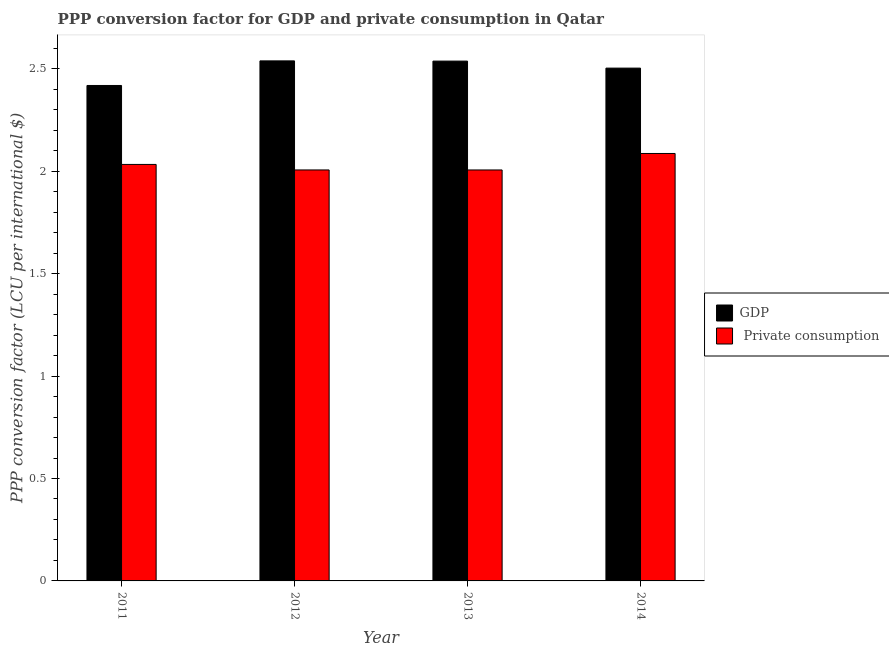How many groups of bars are there?
Provide a short and direct response. 4. Are the number of bars on each tick of the X-axis equal?
Your response must be concise. Yes. How many bars are there on the 4th tick from the left?
Offer a very short reply. 2. How many bars are there on the 1st tick from the right?
Ensure brevity in your answer.  2. What is the label of the 4th group of bars from the left?
Offer a terse response. 2014. What is the ppp conversion factor for private consumption in 2013?
Provide a succinct answer. 2.01. Across all years, what is the maximum ppp conversion factor for gdp?
Keep it short and to the point. 2.54. Across all years, what is the minimum ppp conversion factor for private consumption?
Your answer should be compact. 2.01. In which year was the ppp conversion factor for gdp maximum?
Offer a very short reply. 2012. What is the total ppp conversion factor for gdp in the graph?
Make the answer very short. 10. What is the difference between the ppp conversion factor for private consumption in 2013 and that in 2014?
Keep it short and to the point. -0.08. What is the difference between the ppp conversion factor for gdp in 2012 and the ppp conversion factor for private consumption in 2011?
Your answer should be compact. 0.12. What is the average ppp conversion factor for private consumption per year?
Provide a succinct answer. 2.03. What is the ratio of the ppp conversion factor for gdp in 2012 to that in 2013?
Give a very brief answer. 1. Is the ppp conversion factor for private consumption in 2011 less than that in 2013?
Provide a succinct answer. No. What is the difference between the highest and the second highest ppp conversion factor for gdp?
Provide a succinct answer. 0. What is the difference between the highest and the lowest ppp conversion factor for private consumption?
Give a very brief answer. 0.08. Is the sum of the ppp conversion factor for private consumption in 2011 and 2012 greater than the maximum ppp conversion factor for gdp across all years?
Your answer should be very brief. Yes. What does the 2nd bar from the left in 2013 represents?
Your answer should be very brief.  Private consumption. What does the 2nd bar from the right in 2014 represents?
Offer a very short reply. GDP. What is the difference between two consecutive major ticks on the Y-axis?
Your response must be concise. 0.5. Does the graph contain grids?
Keep it short and to the point. No. Where does the legend appear in the graph?
Provide a short and direct response. Center right. How many legend labels are there?
Your answer should be very brief. 2. How are the legend labels stacked?
Make the answer very short. Vertical. What is the title of the graph?
Ensure brevity in your answer.  PPP conversion factor for GDP and private consumption in Qatar. What is the label or title of the Y-axis?
Make the answer very short. PPP conversion factor (LCU per international $). What is the PPP conversion factor (LCU per international $) in GDP in 2011?
Your answer should be compact. 2.42. What is the PPP conversion factor (LCU per international $) of  Private consumption in 2011?
Make the answer very short. 2.03. What is the PPP conversion factor (LCU per international $) in GDP in 2012?
Provide a succinct answer. 2.54. What is the PPP conversion factor (LCU per international $) in  Private consumption in 2012?
Offer a very short reply. 2.01. What is the PPP conversion factor (LCU per international $) in GDP in 2013?
Offer a very short reply. 2.54. What is the PPP conversion factor (LCU per international $) in  Private consumption in 2013?
Give a very brief answer. 2.01. What is the PPP conversion factor (LCU per international $) in GDP in 2014?
Keep it short and to the point. 2.5. What is the PPP conversion factor (LCU per international $) in  Private consumption in 2014?
Keep it short and to the point. 2.09. Across all years, what is the maximum PPP conversion factor (LCU per international $) in GDP?
Ensure brevity in your answer.  2.54. Across all years, what is the maximum PPP conversion factor (LCU per international $) in  Private consumption?
Offer a terse response. 2.09. Across all years, what is the minimum PPP conversion factor (LCU per international $) of GDP?
Provide a short and direct response. 2.42. Across all years, what is the minimum PPP conversion factor (LCU per international $) of  Private consumption?
Your answer should be compact. 2.01. What is the total PPP conversion factor (LCU per international $) in GDP in the graph?
Your answer should be compact. 10. What is the total PPP conversion factor (LCU per international $) of  Private consumption in the graph?
Provide a succinct answer. 8.13. What is the difference between the PPP conversion factor (LCU per international $) of GDP in 2011 and that in 2012?
Ensure brevity in your answer.  -0.12. What is the difference between the PPP conversion factor (LCU per international $) of  Private consumption in 2011 and that in 2012?
Your answer should be very brief. 0.03. What is the difference between the PPP conversion factor (LCU per international $) of GDP in 2011 and that in 2013?
Your answer should be very brief. -0.12. What is the difference between the PPP conversion factor (LCU per international $) in  Private consumption in 2011 and that in 2013?
Provide a succinct answer. 0.03. What is the difference between the PPP conversion factor (LCU per international $) in GDP in 2011 and that in 2014?
Your response must be concise. -0.08. What is the difference between the PPP conversion factor (LCU per international $) of  Private consumption in 2011 and that in 2014?
Give a very brief answer. -0.05. What is the difference between the PPP conversion factor (LCU per international $) in GDP in 2012 and that in 2013?
Provide a succinct answer. 0. What is the difference between the PPP conversion factor (LCU per international $) in GDP in 2012 and that in 2014?
Keep it short and to the point. 0.04. What is the difference between the PPP conversion factor (LCU per international $) of  Private consumption in 2012 and that in 2014?
Your answer should be very brief. -0.08. What is the difference between the PPP conversion factor (LCU per international $) of GDP in 2013 and that in 2014?
Provide a succinct answer. 0.03. What is the difference between the PPP conversion factor (LCU per international $) in  Private consumption in 2013 and that in 2014?
Provide a short and direct response. -0.08. What is the difference between the PPP conversion factor (LCU per international $) in GDP in 2011 and the PPP conversion factor (LCU per international $) in  Private consumption in 2012?
Your response must be concise. 0.41. What is the difference between the PPP conversion factor (LCU per international $) in GDP in 2011 and the PPP conversion factor (LCU per international $) in  Private consumption in 2013?
Keep it short and to the point. 0.41. What is the difference between the PPP conversion factor (LCU per international $) of GDP in 2011 and the PPP conversion factor (LCU per international $) of  Private consumption in 2014?
Provide a short and direct response. 0.33. What is the difference between the PPP conversion factor (LCU per international $) of GDP in 2012 and the PPP conversion factor (LCU per international $) of  Private consumption in 2013?
Your response must be concise. 0.53. What is the difference between the PPP conversion factor (LCU per international $) in GDP in 2012 and the PPP conversion factor (LCU per international $) in  Private consumption in 2014?
Your answer should be very brief. 0.45. What is the difference between the PPP conversion factor (LCU per international $) of GDP in 2013 and the PPP conversion factor (LCU per international $) of  Private consumption in 2014?
Give a very brief answer. 0.45. What is the average PPP conversion factor (LCU per international $) of GDP per year?
Provide a short and direct response. 2.5. What is the average PPP conversion factor (LCU per international $) in  Private consumption per year?
Ensure brevity in your answer.  2.03. In the year 2011, what is the difference between the PPP conversion factor (LCU per international $) in GDP and PPP conversion factor (LCU per international $) in  Private consumption?
Ensure brevity in your answer.  0.39. In the year 2012, what is the difference between the PPP conversion factor (LCU per international $) of GDP and PPP conversion factor (LCU per international $) of  Private consumption?
Keep it short and to the point. 0.53. In the year 2013, what is the difference between the PPP conversion factor (LCU per international $) of GDP and PPP conversion factor (LCU per international $) of  Private consumption?
Your response must be concise. 0.53. In the year 2014, what is the difference between the PPP conversion factor (LCU per international $) in GDP and PPP conversion factor (LCU per international $) in  Private consumption?
Offer a terse response. 0.42. What is the ratio of the PPP conversion factor (LCU per international $) of GDP in 2011 to that in 2012?
Offer a very short reply. 0.95. What is the ratio of the PPP conversion factor (LCU per international $) in  Private consumption in 2011 to that in 2012?
Provide a short and direct response. 1.01. What is the ratio of the PPP conversion factor (LCU per international $) of GDP in 2011 to that in 2013?
Offer a terse response. 0.95. What is the ratio of the PPP conversion factor (LCU per international $) of  Private consumption in 2011 to that in 2013?
Your response must be concise. 1.01. What is the ratio of the PPP conversion factor (LCU per international $) in GDP in 2011 to that in 2014?
Give a very brief answer. 0.97. What is the ratio of the PPP conversion factor (LCU per international $) in  Private consumption in 2011 to that in 2014?
Your response must be concise. 0.97. What is the ratio of the PPP conversion factor (LCU per international $) of  Private consumption in 2012 to that in 2013?
Ensure brevity in your answer.  1. What is the ratio of the PPP conversion factor (LCU per international $) in GDP in 2012 to that in 2014?
Keep it short and to the point. 1.01. What is the ratio of the PPP conversion factor (LCU per international $) of  Private consumption in 2012 to that in 2014?
Make the answer very short. 0.96. What is the ratio of the PPP conversion factor (LCU per international $) in GDP in 2013 to that in 2014?
Provide a succinct answer. 1.01. What is the ratio of the PPP conversion factor (LCU per international $) of  Private consumption in 2013 to that in 2014?
Your response must be concise. 0.96. What is the difference between the highest and the second highest PPP conversion factor (LCU per international $) in GDP?
Your response must be concise. 0. What is the difference between the highest and the second highest PPP conversion factor (LCU per international $) in  Private consumption?
Keep it short and to the point. 0.05. What is the difference between the highest and the lowest PPP conversion factor (LCU per international $) in GDP?
Offer a terse response. 0.12. What is the difference between the highest and the lowest PPP conversion factor (LCU per international $) of  Private consumption?
Your answer should be compact. 0.08. 